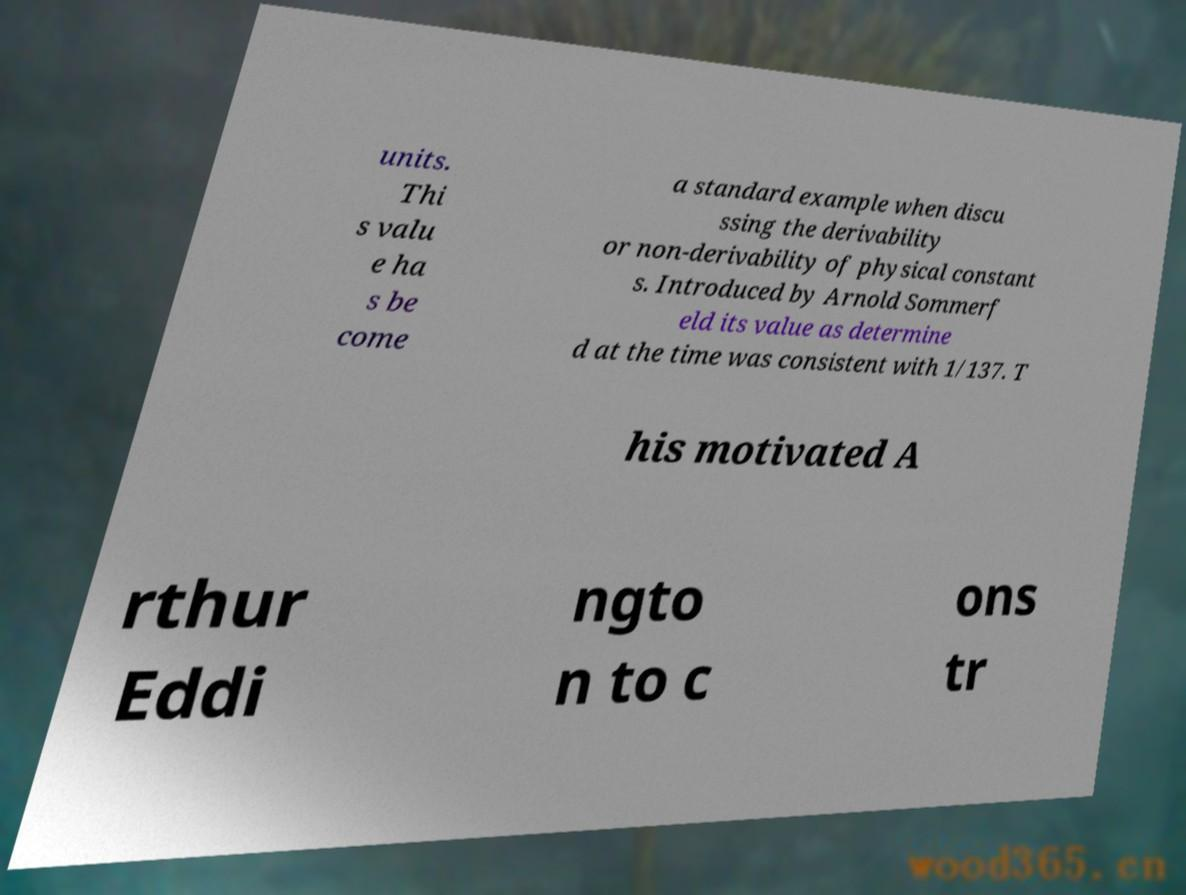Please read and relay the text visible in this image. What does it say? units. Thi s valu e ha s be come a standard example when discu ssing the derivability or non-derivability of physical constant s. Introduced by Arnold Sommerf eld its value as determine d at the time was consistent with 1/137. T his motivated A rthur Eddi ngto n to c ons tr 